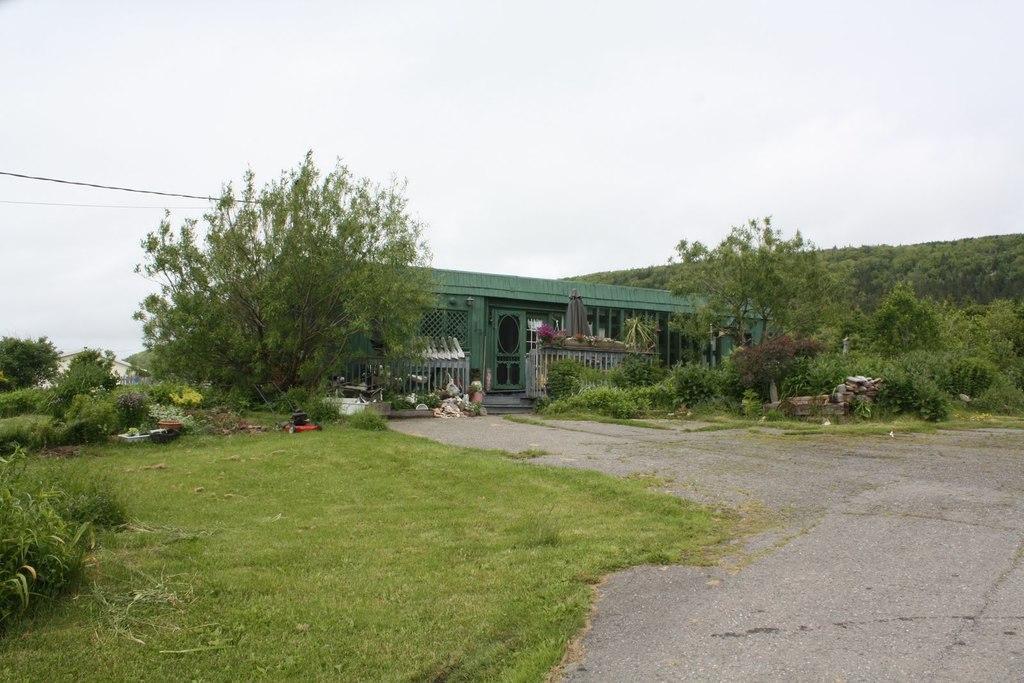Can you describe this image briefly? In this picture there is a road and there is a greenery ground,few plants and trees on either sides of it and there is a building which is in green color and there is another building in the left corner. 